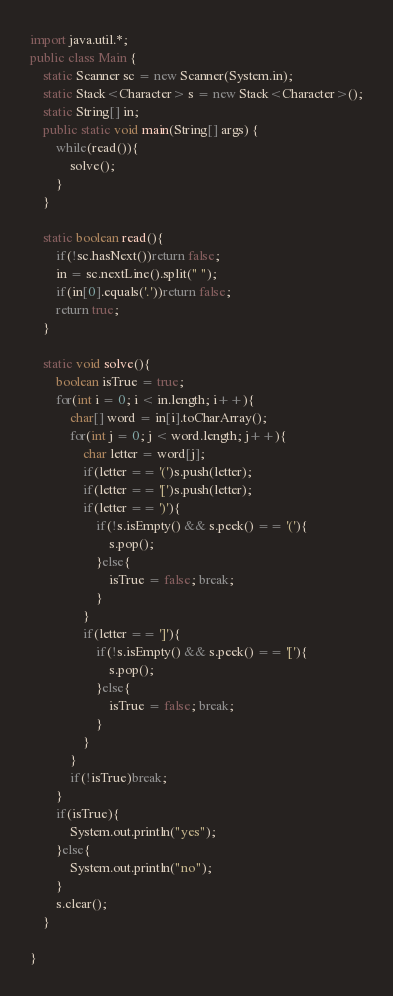<code> <loc_0><loc_0><loc_500><loc_500><_Java_>import java.util.*;
public class Main {
	static Scanner sc = new Scanner(System.in);
	static Stack<Character> s = new Stack<Character>();
	static String[] in;
	public static void main(String[] args) {
		while(read()){
			solve();
		}
	}
	
	static boolean read(){
		if(!sc.hasNext())return false;
		in = sc.nextLine().split(" ");
		if(in[0].equals('.'))return false;
		return true;
	}
	
	static void solve(){
		boolean isTrue = true;
		for(int i = 0; i < in.length; i++){
			char[] word = in[i].toCharArray();
			for(int j = 0; j < word.length; j++){
				char letter = word[j];
				if(letter == '(')s.push(letter);
				if(letter == '[')s.push(letter);
				if(letter == ')'){
					if(!s.isEmpty() && s.peek() == '('){
						s.pop();
					}else{
						isTrue = false; break;
					}
				}
				if(letter == ']'){
					if(!s.isEmpty() && s.peek() == '['){
						s.pop();
					}else{
						isTrue = false; break;
					}
				}
			}
			if(!isTrue)break;
		}
		if(isTrue){
			System.out.println("yes");
		}else{
			System.out.println("no");
		}
		s.clear();
	}

}</code> 